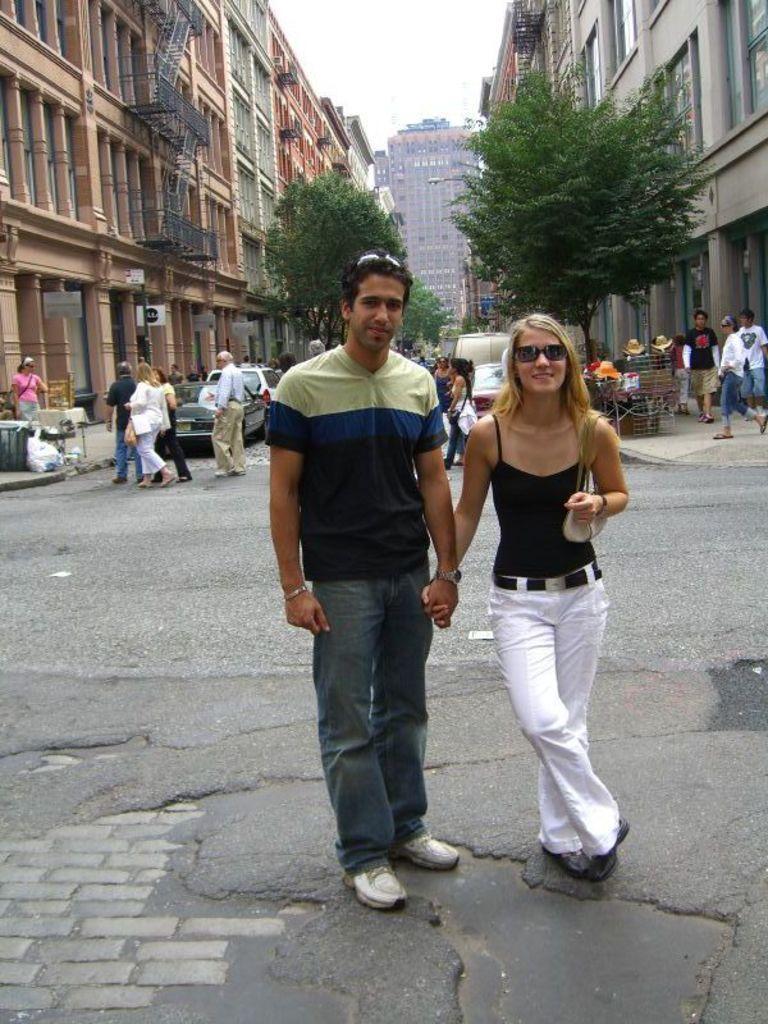Please provide a concise description of this image. In this image we can see people and there are vehicles on the road. In the background there are trees, buildings and sky. 